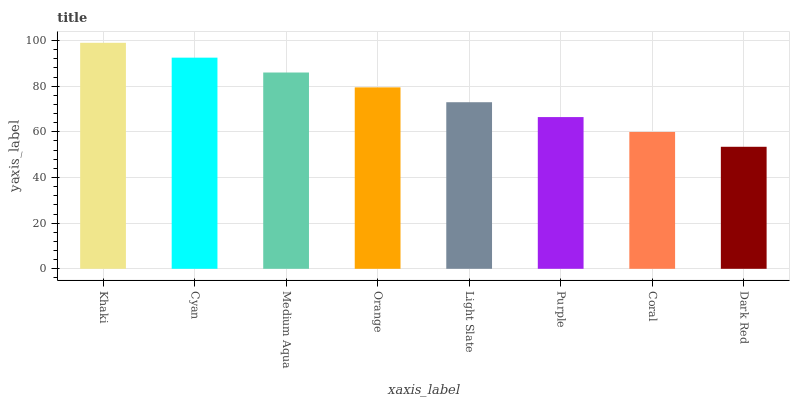Is Dark Red the minimum?
Answer yes or no. Yes. Is Khaki the maximum?
Answer yes or no. Yes. Is Cyan the minimum?
Answer yes or no. No. Is Cyan the maximum?
Answer yes or no. No. Is Khaki greater than Cyan?
Answer yes or no. Yes. Is Cyan less than Khaki?
Answer yes or no. Yes. Is Cyan greater than Khaki?
Answer yes or no. No. Is Khaki less than Cyan?
Answer yes or no. No. Is Orange the high median?
Answer yes or no. Yes. Is Light Slate the low median?
Answer yes or no. Yes. Is Light Slate the high median?
Answer yes or no. No. Is Medium Aqua the low median?
Answer yes or no. No. 